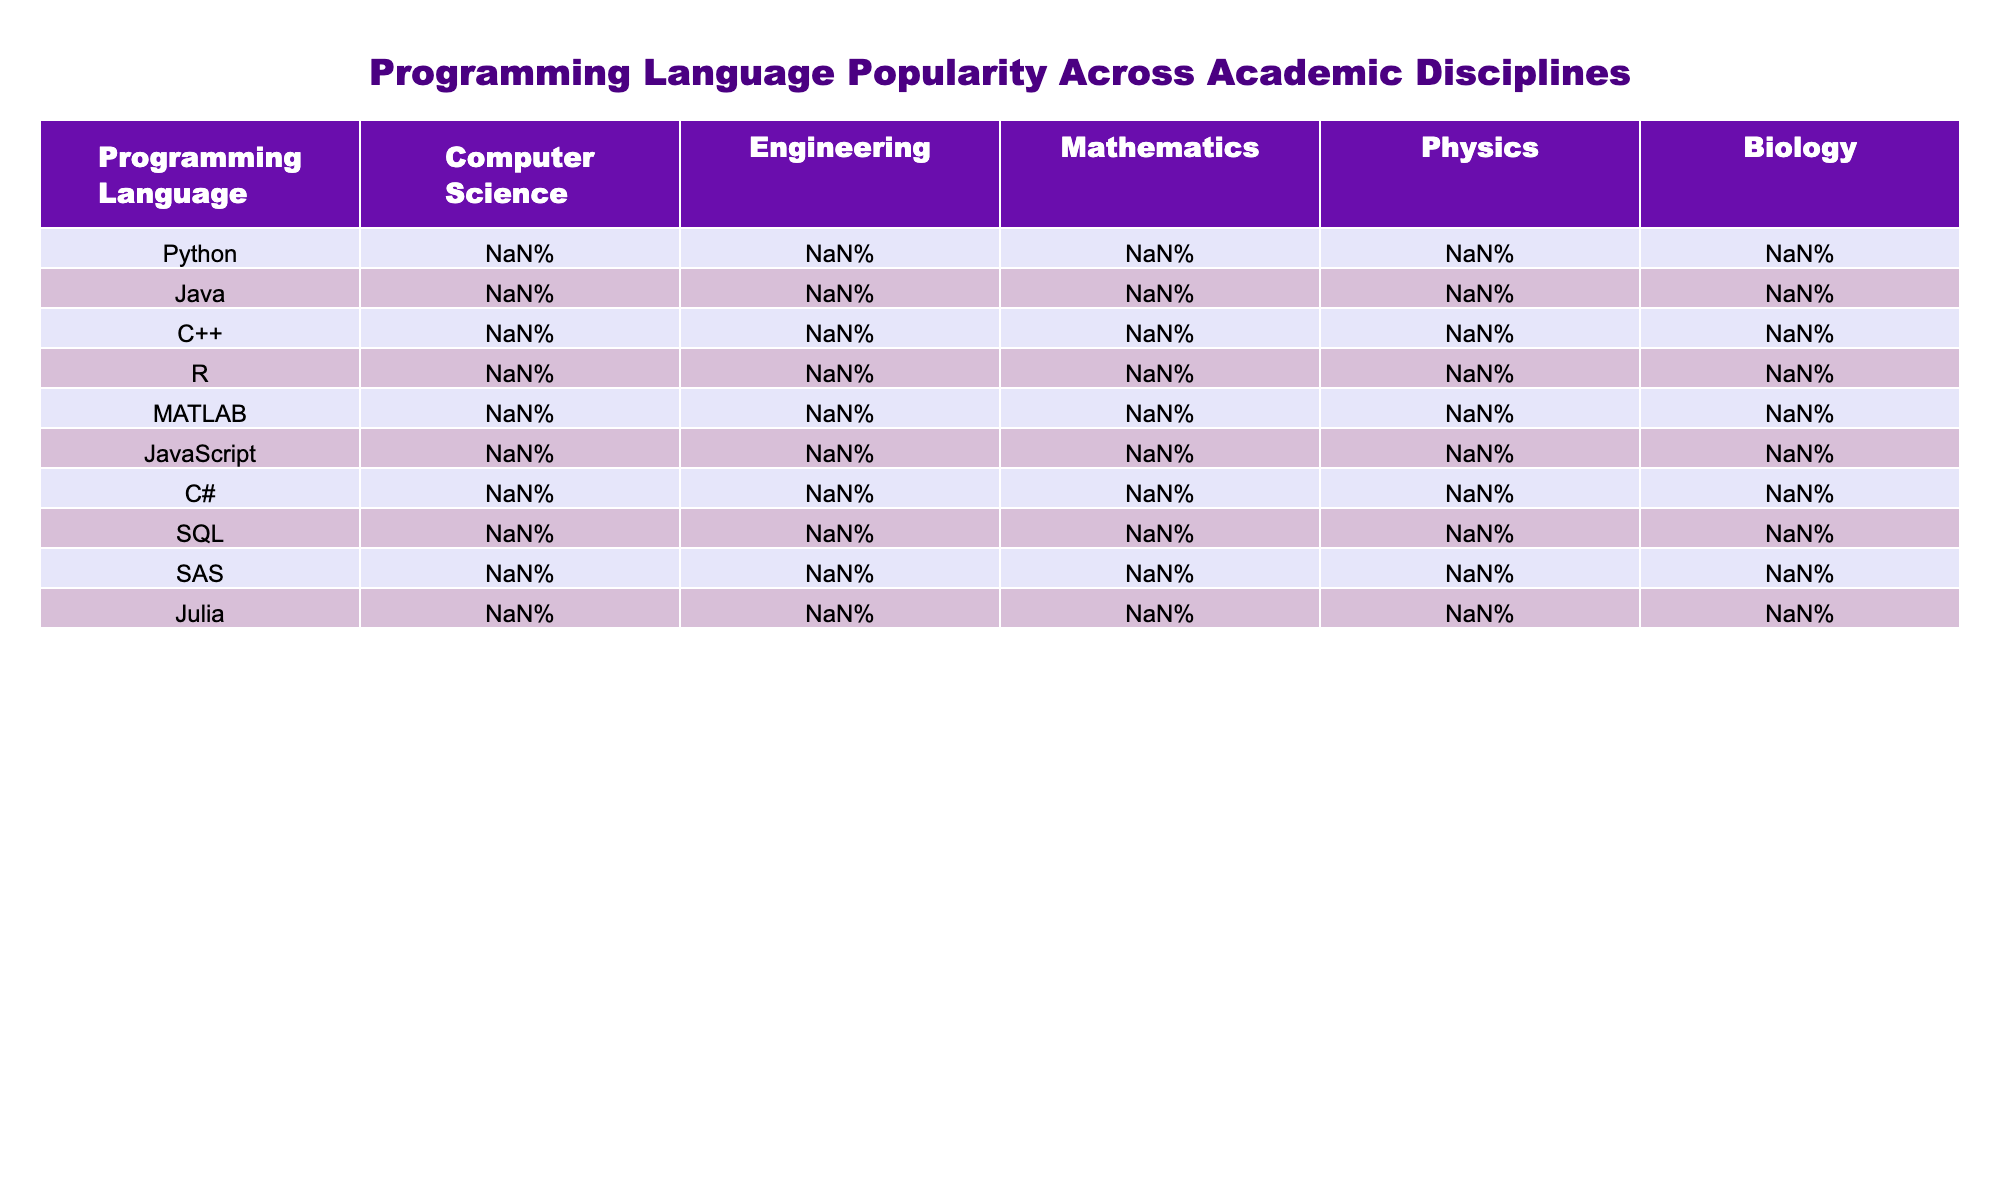What is the most popular programming language in Computer Science? In the Computer Science column, the highest percentage is for Python at 85%.
Answer: Python Which programming language has the lowest popularity in Biology? In the Biology column, the lowest percentage is for JavaScript at 5%.
Answer: JavaScript What is the difference in popularity between Python and Java in Engineering? Python has a popularity of 60% and Java has 55%, so the difference is 60% - 55% = 5%.
Answer: 5% Is C++ more popular in Mathematics than in Physics? C++ has a popularity of 25% in Mathematics and 30% in Physics; since 25% is less than 30%, the statement is false.
Answer: No What is the average popularity of R across all disciplines? The percentages for R are: 30%, 20%, 40%, 35%, and 50%. The sum is 30 + 20 + 40 + 35 + 50 = 175. There are 5 disciplines, so the average is 175/5 = 35%.
Answer: 35% Which programming language is equally popular in Engineering and Biology? In Engineering, MATLAB has 50% popularity and in Biology it has 40%. No language has the same popularity in both.
Answer: None What is the most popular programming language across all disciplines combined? The language with the highest total popularity when summed across all disciplines is Python: 85 + 60 + 45 + 40 + 35 = 265, which is more than any other language.
Answer: Python Does SQL enjoy greater popularity in Computer Science or Mathematics? SQL has a popularity of 55% in Computer Science and 25% in Mathematics. Therefore, SQL is more popular in Computer Science.
Answer: Computer Science What is the total popularity of programming languages in Physics? The popularity percentages for Physics are 40%, 15%, 30%, 35%, 55%, 5%, 10%, 20%, 25%, and 25%. Summing these gives 40 + 15 + 30 + 35 + 55 + 5 + 10 + 20 + 25 + 25 = 320%.
Answer: 320% Which two programming languages are most popular in Mathematics? The rankings in Mathematics are Python at 45% and R at 40%. Therefore, Python and R are the top two in this discipline.
Answer: Python and R 